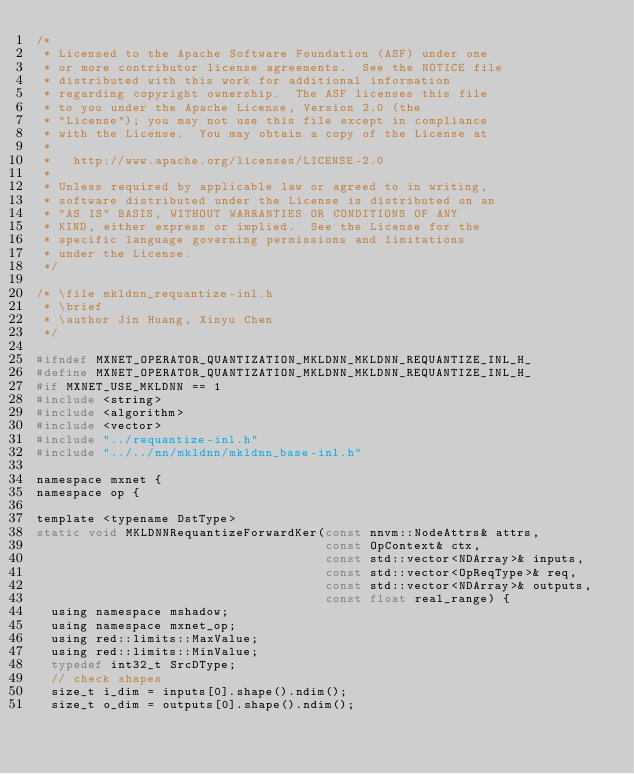<code> <loc_0><loc_0><loc_500><loc_500><_C_>/*
 * Licensed to the Apache Software Foundation (ASF) under one
 * or more contributor license agreements.  See the NOTICE file
 * distributed with this work for additional information
 * regarding copyright ownership.  The ASF licenses this file
 * to you under the Apache License, Version 2.0 (the
 * "License"); you may not use this file except in compliance
 * with the License.  You may obtain a copy of the License at
 *
 *   http://www.apache.org/licenses/LICENSE-2.0
 *
 * Unless required by applicable law or agreed to in writing,
 * software distributed under the License is distributed on an
 * "AS IS" BASIS, WITHOUT WARRANTIES OR CONDITIONS OF ANY
 * KIND, either express or implied.  See the License for the
 * specific language governing permissions and limitations
 * under the License.
 */

/* \file mkldnn_requantize-inl.h
 * \brief
 * \author Jin Huang, Xinyu Chen
 */

#ifndef MXNET_OPERATOR_QUANTIZATION_MKLDNN_MKLDNN_REQUANTIZE_INL_H_
#define MXNET_OPERATOR_QUANTIZATION_MKLDNN_MKLDNN_REQUANTIZE_INL_H_
#if MXNET_USE_MKLDNN == 1
#include <string>
#include <algorithm>
#include <vector>
#include "../requantize-inl.h"
#include "../../nn/mkldnn/mkldnn_base-inl.h"

namespace mxnet {
namespace op {

template <typename DstType>
static void MKLDNNRequantizeForwardKer(const nnvm::NodeAttrs& attrs,
                                       const OpContext& ctx,
                                       const std::vector<NDArray>& inputs,
                                       const std::vector<OpReqType>& req,
                                       const std::vector<NDArray>& outputs,
                                       const float real_range) {
  using namespace mshadow;
  using namespace mxnet_op;
  using red::limits::MaxValue;
  using red::limits::MinValue;
  typedef int32_t SrcDType;
  // check shapes
  size_t i_dim = inputs[0].shape().ndim();
  size_t o_dim = outputs[0].shape().ndim();</code> 